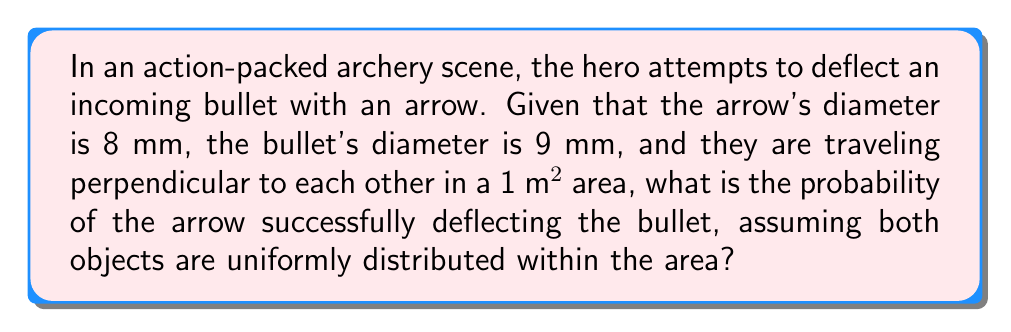Give your solution to this math problem. To solve this problem, we need to follow these steps:

1. Calculate the area where a collision can occur:
   The collision area is determined by the sum of the diameters of the arrow and bullet.
   Collision width = Arrow diameter + Bullet diameter
   $w = 8 \text{ mm} + 9 \text{ mm} = 17 \text{ mm} = 0.017 \text{ m}$

2. Calculate the total area where a collision can happen:
   This area is a strip across the 1 m² area with the width we calculated.
   Collision area = Width × Length of the area
   $A_c = 0.017 \text{ m} \times 1 \text{ m} = 0.017 \text{ m}^2$

3. Calculate the probability:
   The probability is the ratio of the collision area to the total area.
   $$P(\text{collision}) = \frac{\text{Collision area}}{\text{Total area}} = \frac{0.017 \text{ m}^2}{1 \text{ m}^2} = 0.017$$

Therefore, the probability of the arrow successfully deflecting the bullet is 0.017 or 1.7%.
Answer: 0.017 